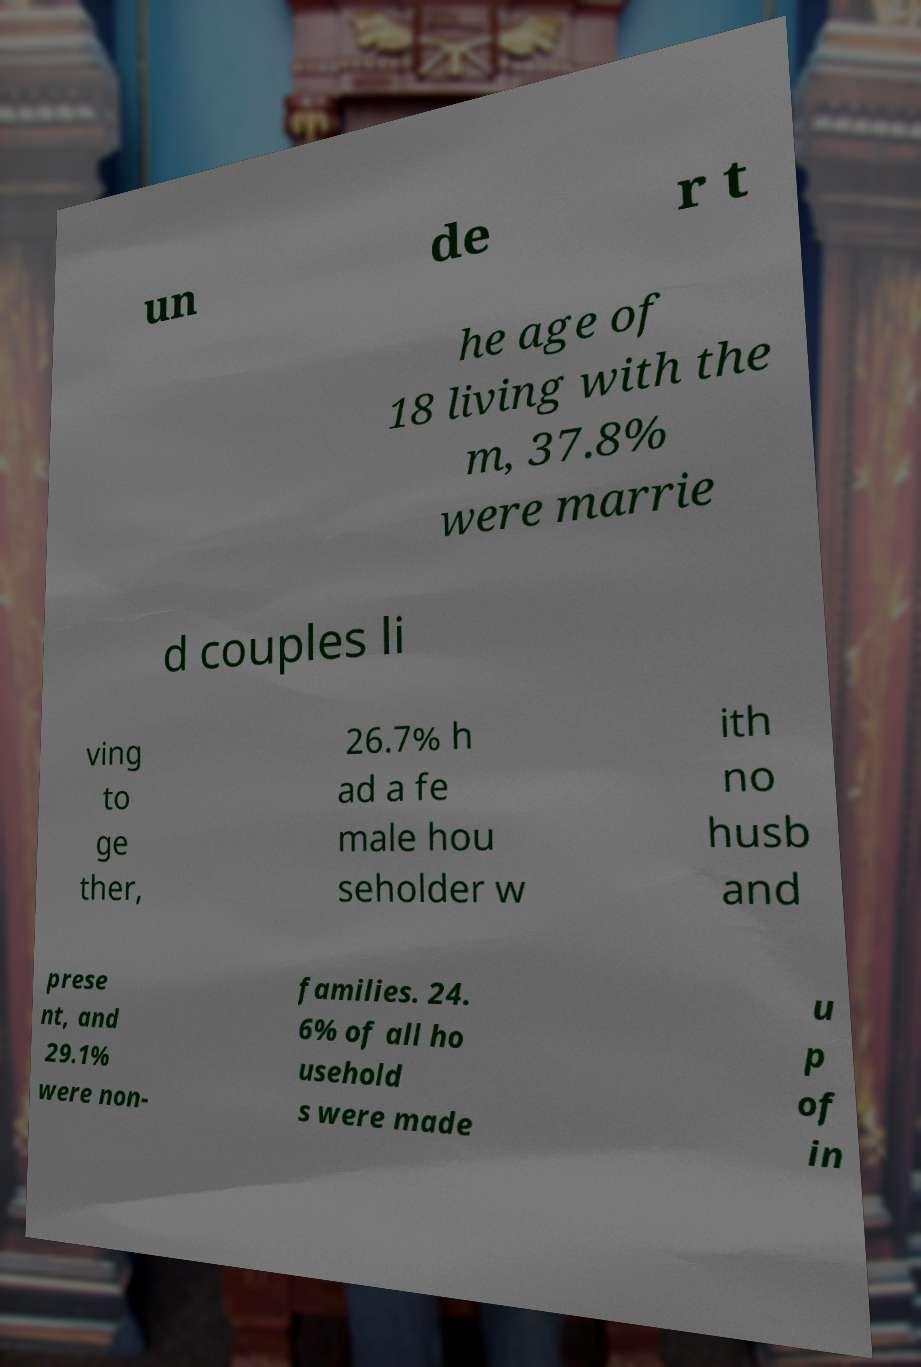Could you extract and type out the text from this image? un de r t he age of 18 living with the m, 37.8% were marrie d couples li ving to ge ther, 26.7% h ad a fe male hou seholder w ith no husb and prese nt, and 29.1% were non- families. 24. 6% of all ho usehold s were made u p of in 